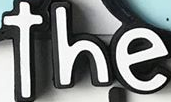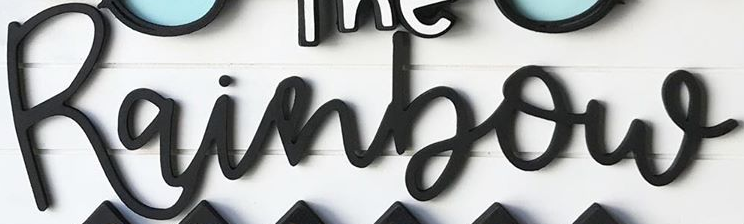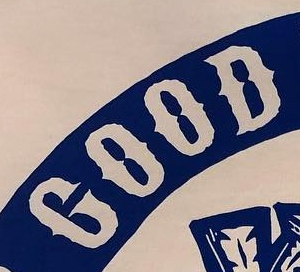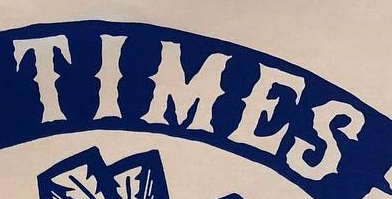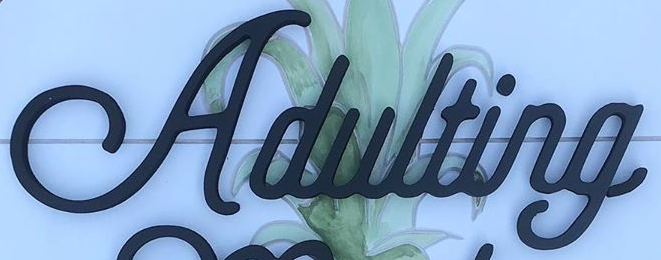Identify the words shown in these images in order, separated by a semicolon. the; Rainbow; GOOD; TIMES; Adulting 